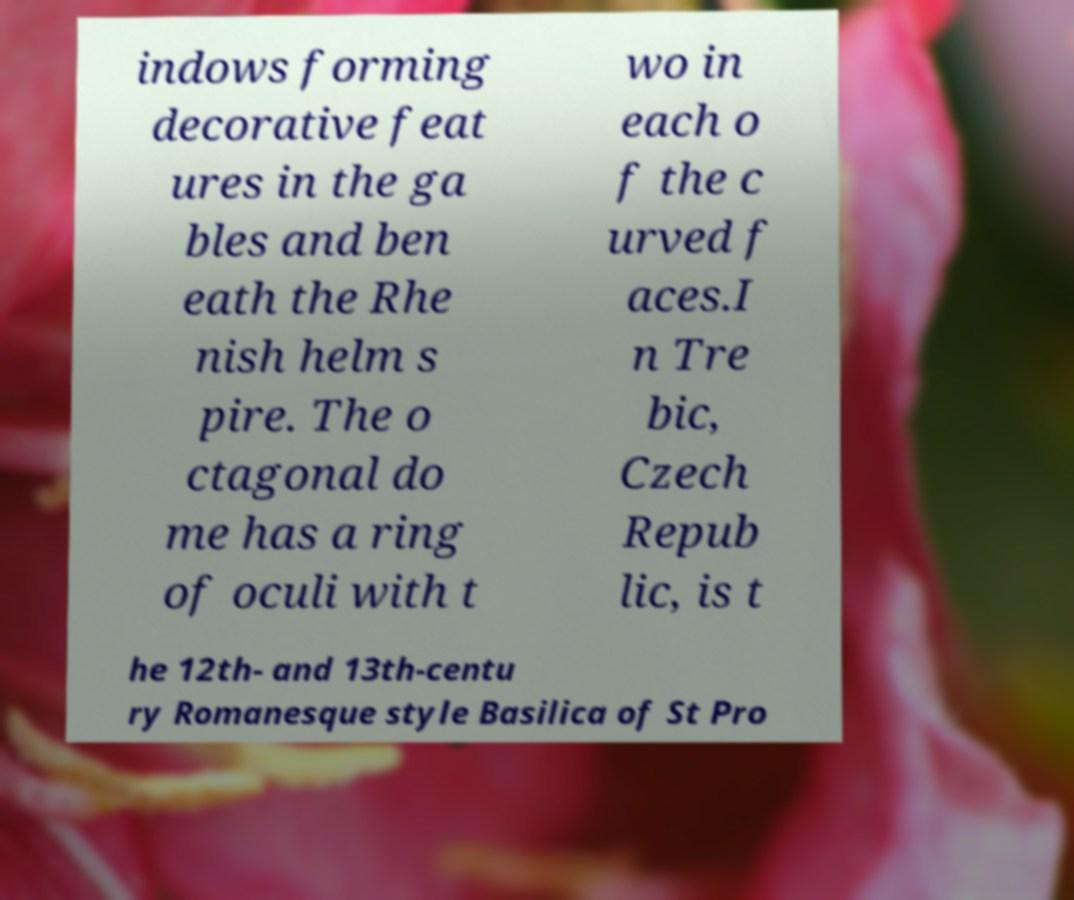Could you extract and type out the text from this image? indows forming decorative feat ures in the ga bles and ben eath the Rhe nish helm s pire. The o ctagonal do me has a ring of oculi with t wo in each o f the c urved f aces.I n Tre bic, Czech Repub lic, is t he 12th- and 13th-centu ry Romanesque style Basilica of St Pro 